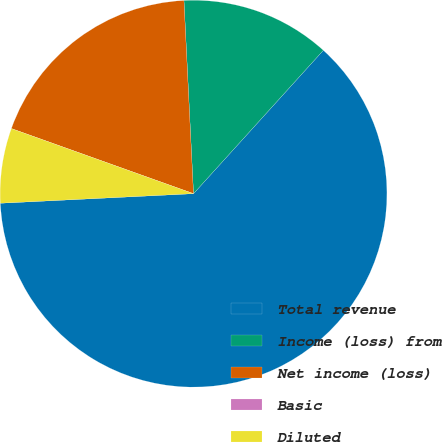<chart> <loc_0><loc_0><loc_500><loc_500><pie_chart><fcel>Total revenue<fcel>Income (loss) from<fcel>Net income (loss)<fcel>Basic<fcel>Diluted<nl><fcel>62.5%<fcel>12.5%<fcel>18.75%<fcel>0.0%<fcel>6.25%<nl></chart> 